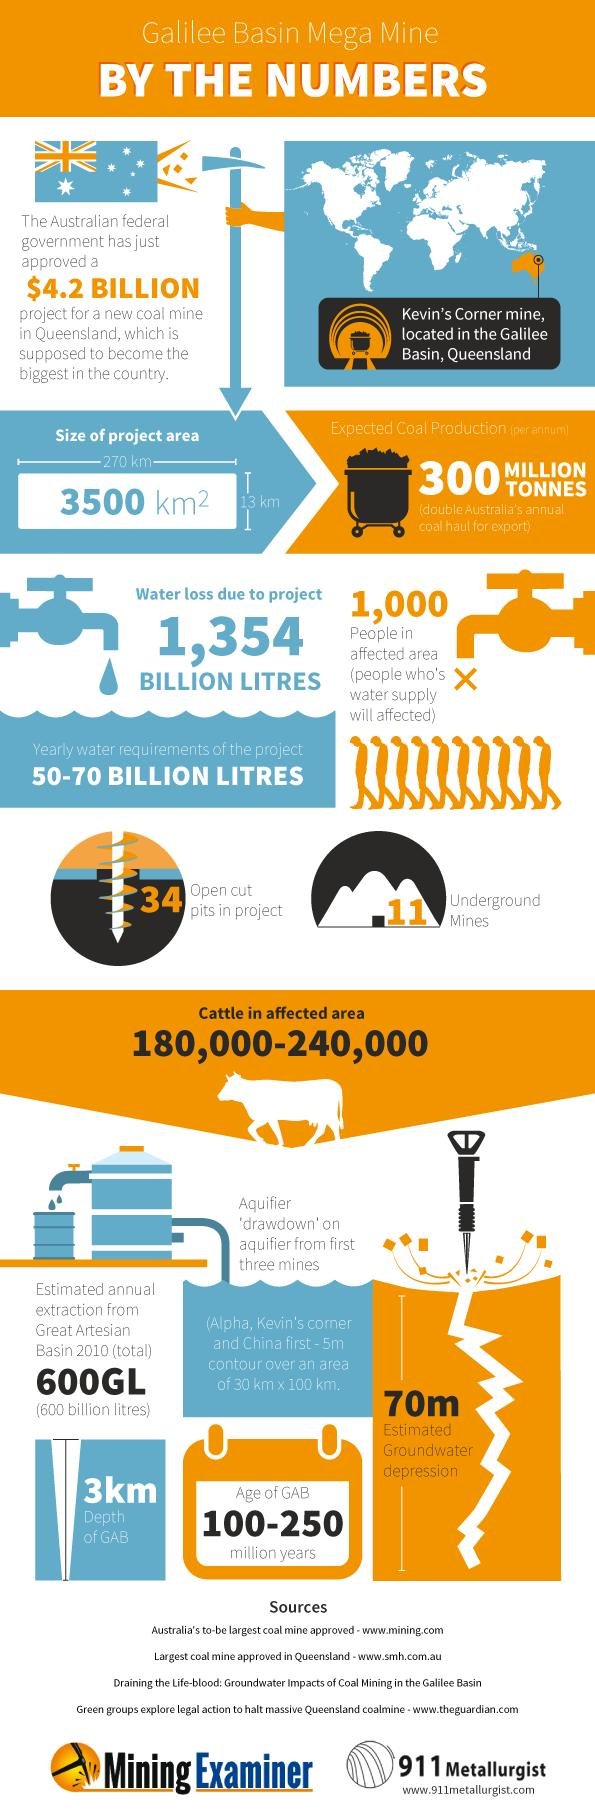Specify some key components in this picture. The area of the new coal mine in Queensland is 3,500 km2. The expected water loss from the new coal mine project in Queensland is approximately 1,354 billion liters. The infographics show 9 men or 10 men's pictures. The length of the project area is approximately 270 kilometers. The project area has a breadth of 13 km. 